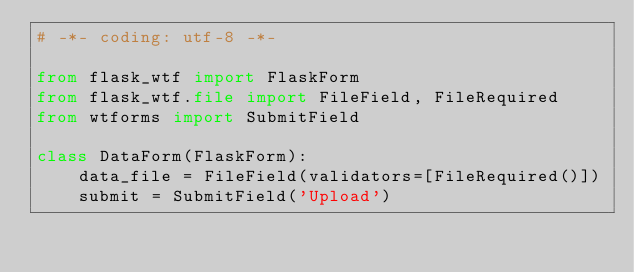Convert code to text. <code><loc_0><loc_0><loc_500><loc_500><_Python_># -*- coding: utf-8 -*-

from flask_wtf import FlaskForm
from flask_wtf.file import FileField, FileRequired
from wtforms import SubmitField

class DataForm(FlaskForm):
    data_file = FileField(validators=[FileRequired()])
    submit = SubmitField('Upload')</code> 